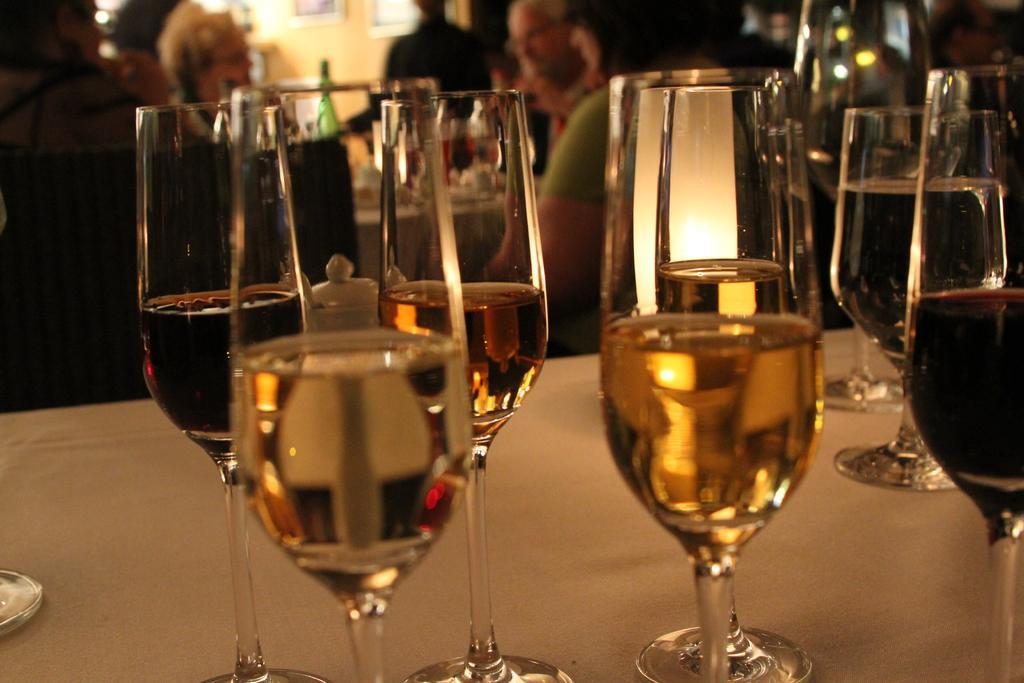Could you give a brief overview of what you see in this image? In this image i can see there are few wine glass bottles on the table and also behind this bottles I can see there are group of people was standing. 